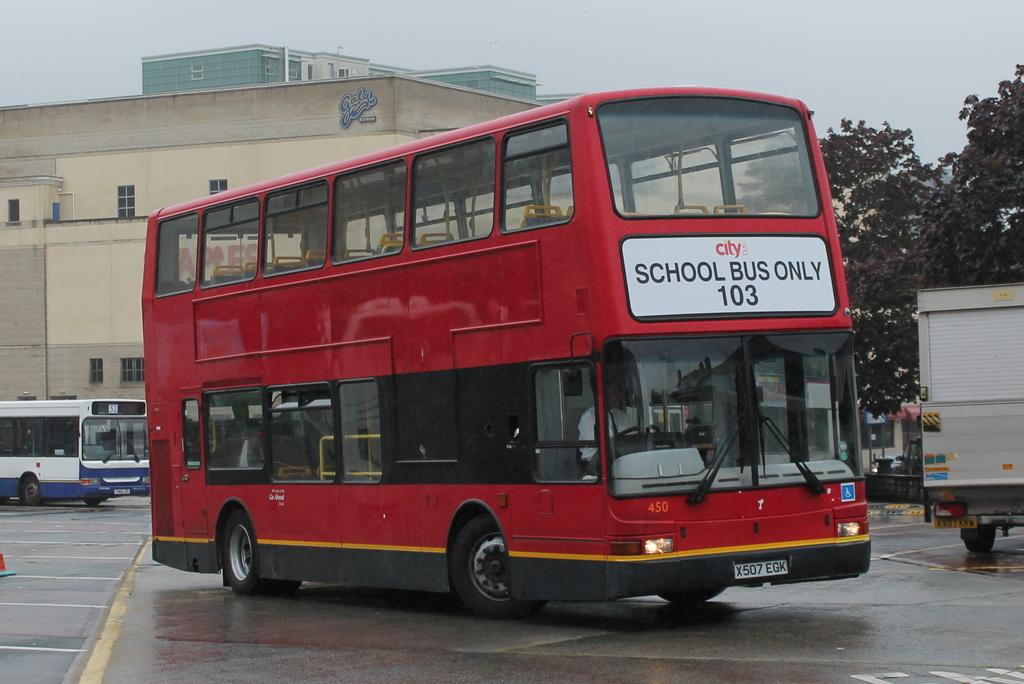<image>
Provide a brief description of the given image. Double decker bus saying "School bus only" on the front. 